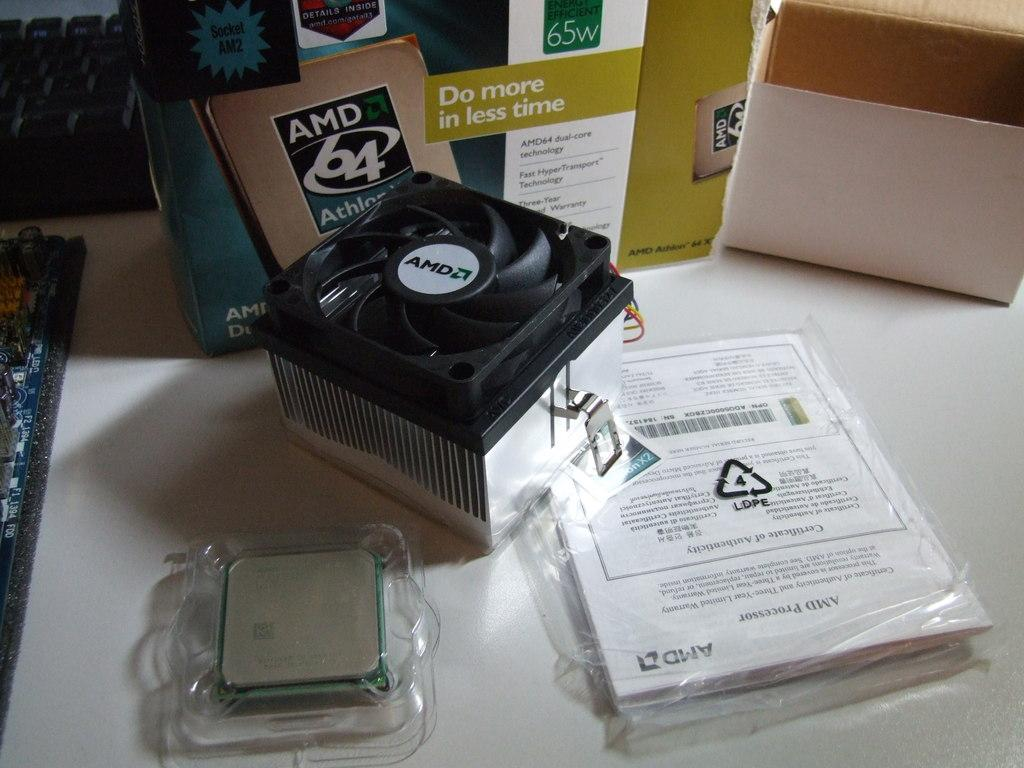<image>
Relay a brief, clear account of the picture shown. An AMD 64 chip sits near its box on a table. 